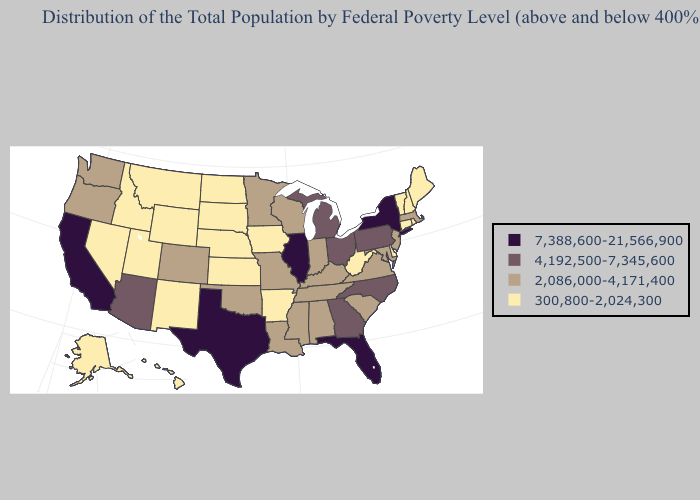What is the highest value in the MidWest ?
Keep it brief. 7,388,600-21,566,900. What is the lowest value in the South?
Keep it brief. 300,800-2,024,300. Does South Carolina have the lowest value in the USA?
Give a very brief answer. No. Does Kansas have the same value as Wisconsin?
Short answer required. No. What is the lowest value in the USA?
Be succinct. 300,800-2,024,300. What is the lowest value in the MidWest?
Keep it brief. 300,800-2,024,300. What is the highest value in the USA?
Be succinct. 7,388,600-21,566,900. Which states have the lowest value in the USA?
Quick response, please. Alaska, Arkansas, Connecticut, Delaware, Hawaii, Idaho, Iowa, Kansas, Maine, Montana, Nebraska, Nevada, New Hampshire, New Mexico, North Dakota, Rhode Island, South Dakota, Utah, Vermont, West Virginia, Wyoming. Does Indiana have a higher value than North Dakota?
Give a very brief answer. Yes. Does Louisiana have a higher value than Idaho?
Be succinct. Yes. Among the states that border New Hampshire , does Maine have the highest value?
Short answer required. No. Name the states that have a value in the range 4,192,500-7,345,600?
Be succinct. Arizona, Georgia, Michigan, North Carolina, Ohio, Pennsylvania. What is the value of Rhode Island?
Concise answer only. 300,800-2,024,300. Does Delaware have the lowest value in the South?
Concise answer only. Yes. 